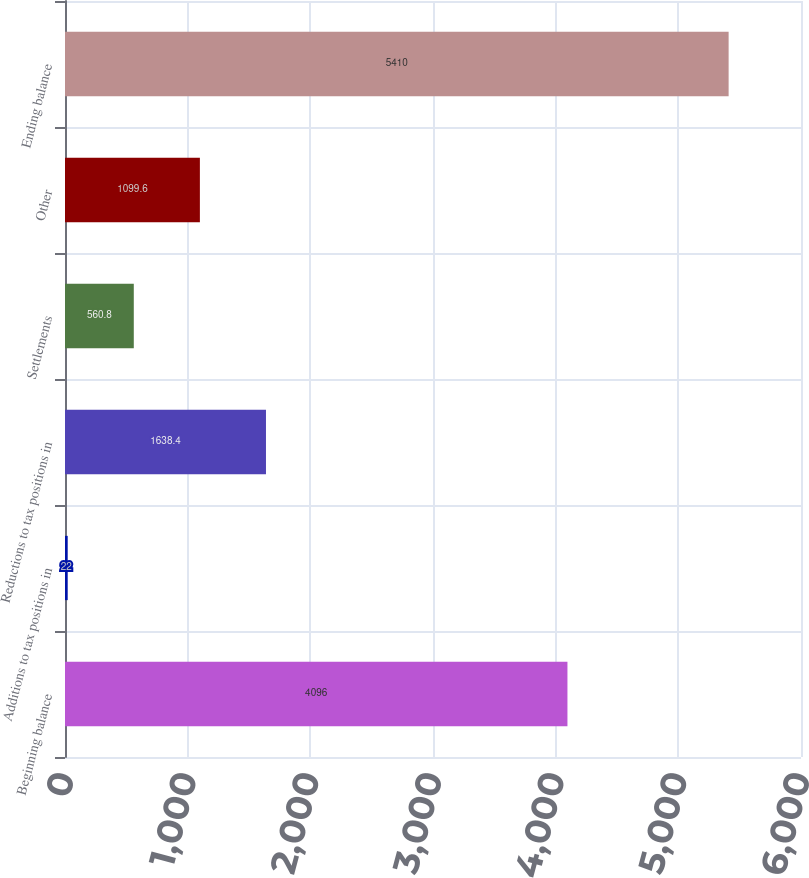Convert chart to OTSL. <chart><loc_0><loc_0><loc_500><loc_500><bar_chart><fcel>Beginning balance<fcel>Additions to tax positions in<fcel>Reductions to tax positions in<fcel>Settlements<fcel>Other<fcel>Ending balance<nl><fcel>4096<fcel>22<fcel>1638.4<fcel>560.8<fcel>1099.6<fcel>5410<nl></chart> 